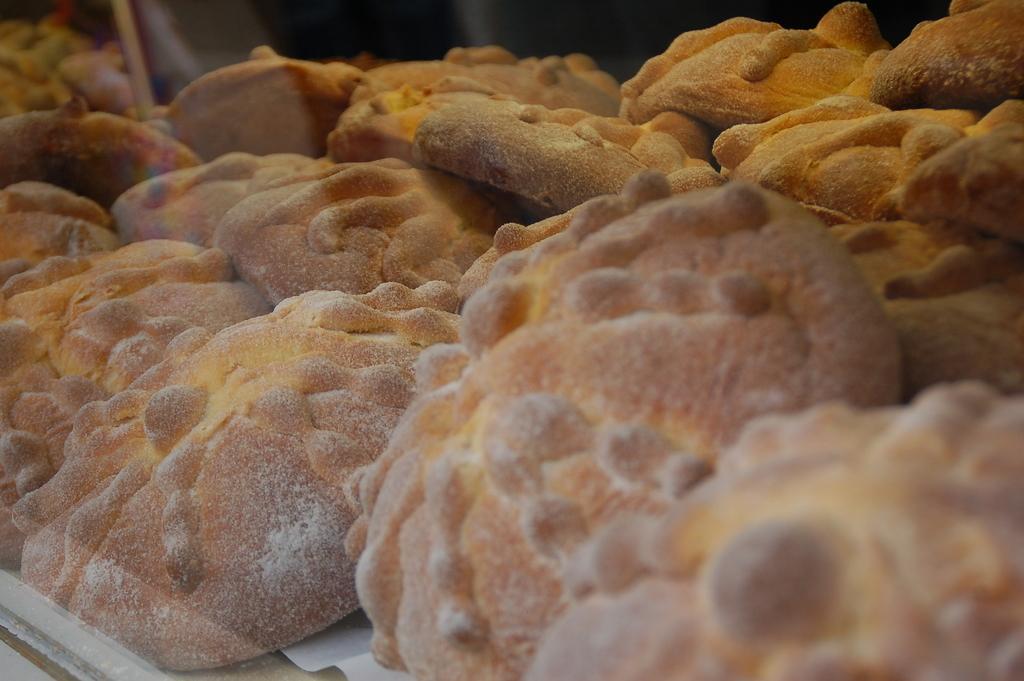Can you describe this image briefly? In this image we can see baked food item. 